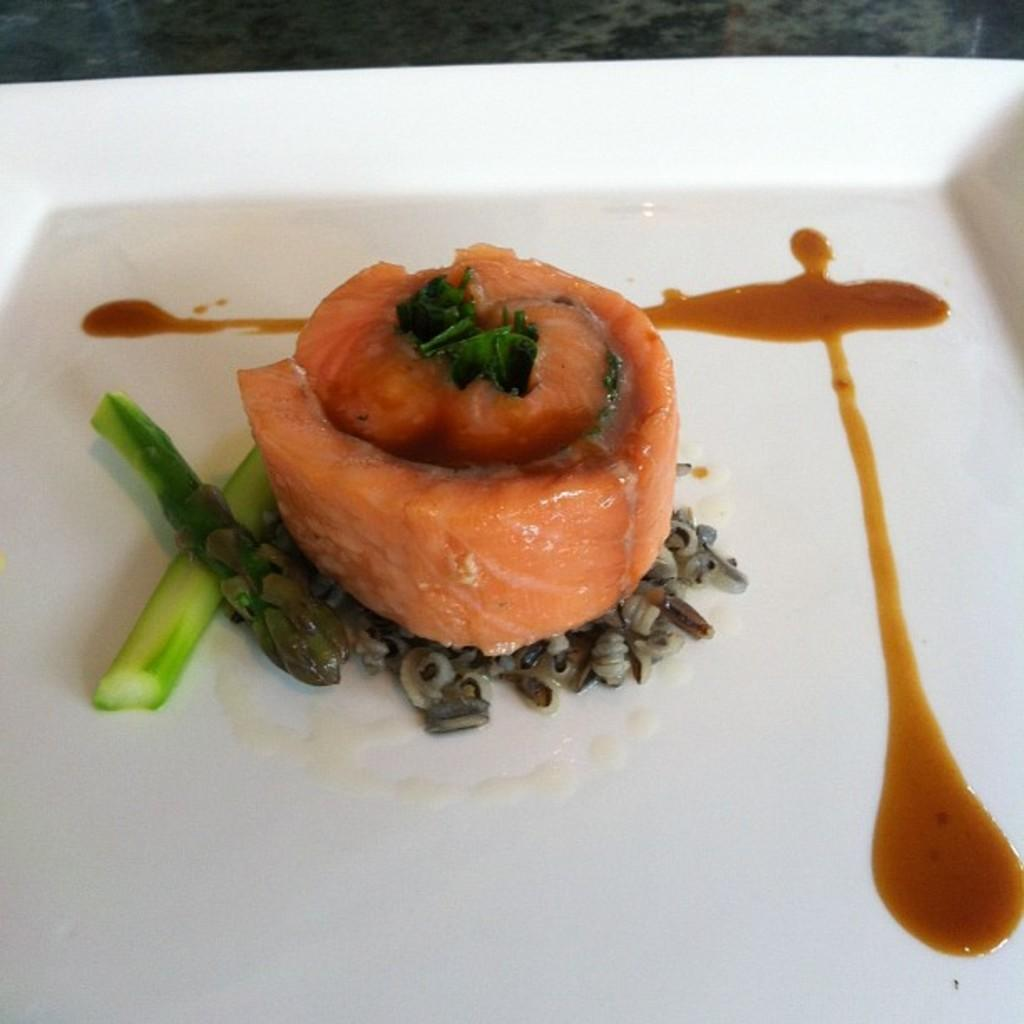What is the main object in the center of the image? There is a white color palette in the center of the image. What is on the palette? The palette contains food items. Can you describe any other objects visible in the image? There are other objects visible in the background of the image. How does the palette lead people to the harbor in the image? There is no harbor present in the image, and the palette does not lead people anywhere. 